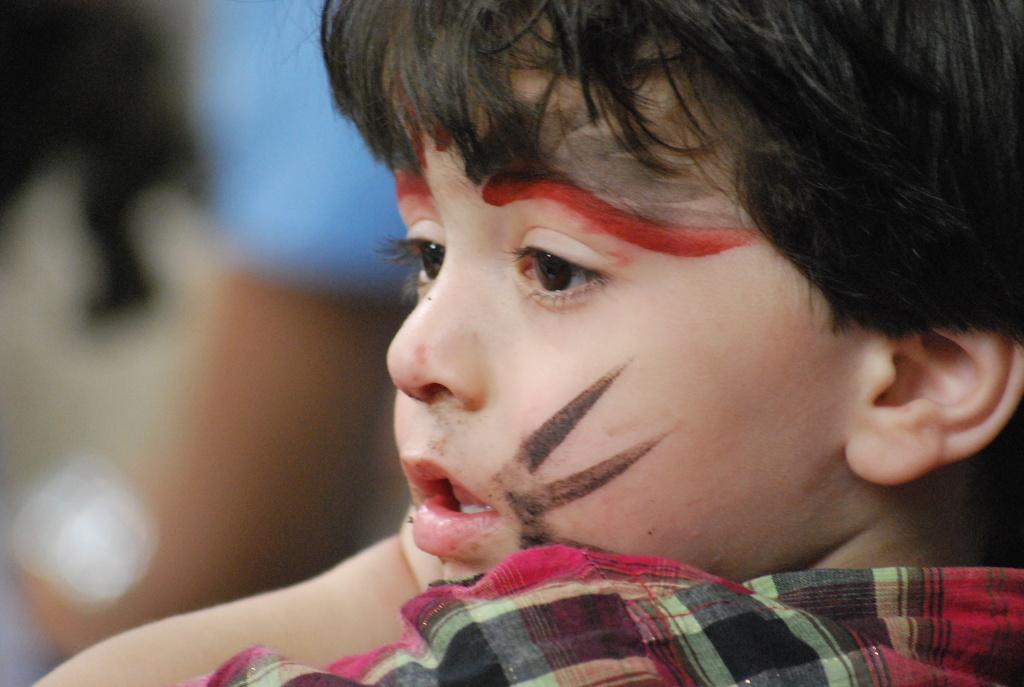What is the main subject of the image? The main subject of the image is a kid. What can be observed on the kid's face? The kid has paint on his face. What colors are visible on the paint on the kid's face? The paint on the kid's face is in red and black colors. How far did the kid fall in the image? There is no indication in the image that the kid has fallen, and therefore no distance can be determined. 